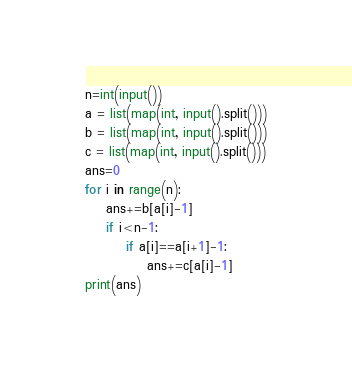Convert code to text. <code><loc_0><loc_0><loc_500><loc_500><_Python_>n=int(input())
a = list(map(int, input().split()))
b = list(map(int, input().split()))
c = list(map(int, input().split()))
ans=0
for i in range(n):
    ans+=b[a[i]-1]
    if i<n-1:
        if a[i]==a[i+1]-1:
            ans+=c[a[i]-1]
print(ans)</code> 